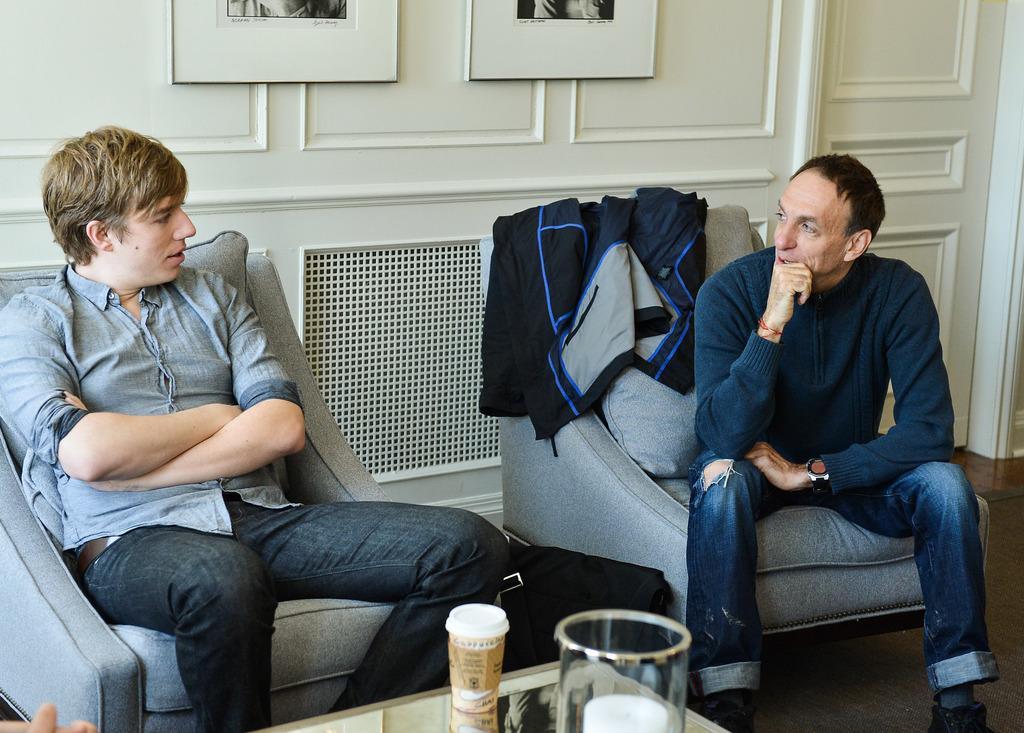Please provide a concise description of this image. In this image there are persons sitting on a sofa in the center. In the front there is a glass and a jar on the table. In the background there are frames on the wall and there is a door which is white in colour. 